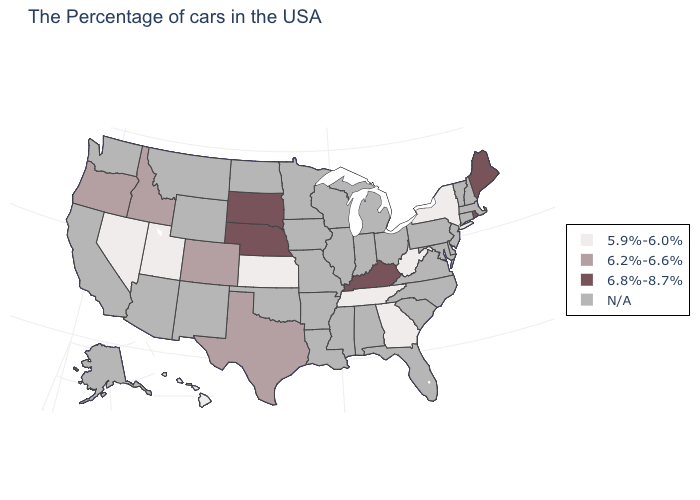Is the legend a continuous bar?
Keep it brief. No. Which states hav the highest value in the MidWest?
Quick response, please. Nebraska, South Dakota. What is the value of Missouri?
Answer briefly. N/A. What is the value of Texas?
Quick response, please. 6.2%-6.6%. Does Kentucky have the lowest value in the South?
Write a very short answer. No. What is the value of Missouri?
Answer briefly. N/A. Which states hav the highest value in the Northeast?
Be succinct. Maine, Rhode Island. Which states hav the highest value in the South?
Give a very brief answer. Kentucky. Does the map have missing data?
Short answer required. Yes. What is the value of Mississippi?
Be succinct. N/A. Name the states that have a value in the range 5.9%-6.0%?
Short answer required. New York, West Virginia, Georgia, Tennessee, Kansas, Utah, Nevada, Hawaii. What is the value of New Hampshire?
Be succinct. N/A. 